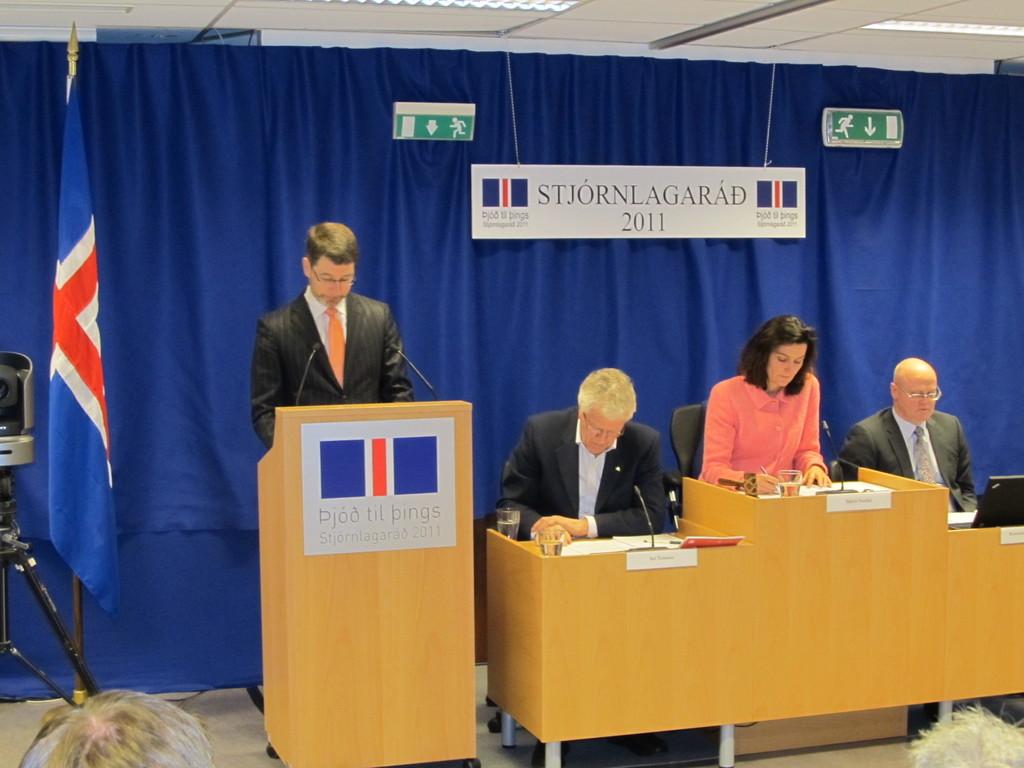Which year was this meeting held?
Ensure brevity in your answer.  2011. What does it say above 2011?
Offer a terse response. Stjornlagarad. 